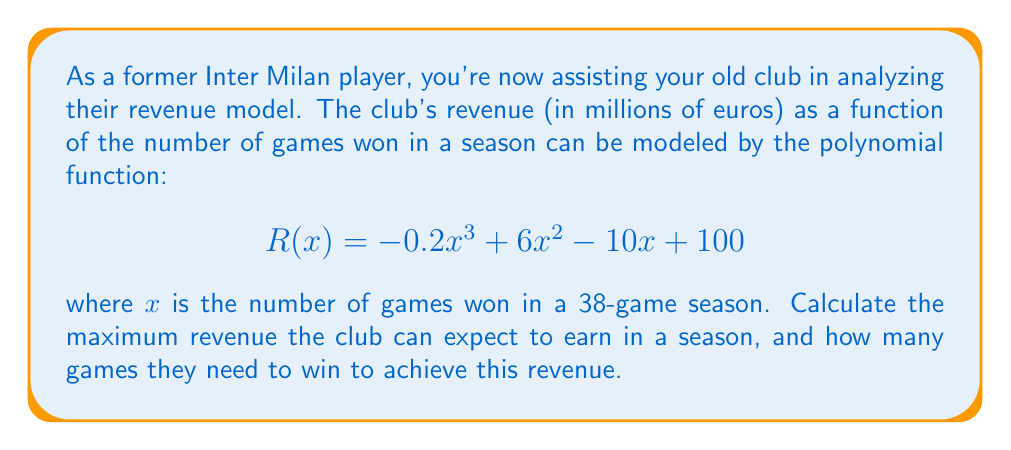Solve this math problem. To find the maximum revenue and the corresponding number of games won, we need to follow these steps:

1) First, we need to find the derivative of the revenue function:
   $$R'(x) = -0.6x^2 + 12x - 10$$

2) To find the maximum, we set the derivative equal to zero and solve for x:
   $$-0.6x^2 + 12x - 10 = 0$$

3) This is a quadratic equation. We can solve it using the quadratic formula:
   $$x = \frac{-b \pm \sqrt{b^2 - 4ac}}{2a}$$
   where $a = -0.6$, $b = 12$, and $c = -10$

4) Plugging in these values:
   $$x = \frac{-12 \pm \sqrt{12^2 - 4(-0.6)(-10)}}{2(-0.6)}$$
   $$= \frac{-12 \pm \sqrt{144 - 24}}{-1.2}$$
   $$= \frac{-12 \pm \sqrt{120}}{-1.2}$$
   $$= \frac{-12 \pm 10.95}{-1.2}$$

5) This gives us two solutions:
   $$x_1 = \frac{-12 + 10.95}{-1.2} \approx 0.875$$
   $$x_2 = \frac{-12 - 10.95}{-1.2} \approx 19.125$$

6) Since we're looking for the maximum revenue, and the leading coefficient of our original function is negative (indicating it opens downward), we choose the larger x-value: 19.125

7) However, since the number of games won must be a whole number, we round this to 19 games.

8) To find the maximum revenue, we plug x = 19 into our original function:
   $$R(19) = -0.2(19)^3 + 6(19)^2 - 10(19) + 100$$
   $$= -0.2(6859) + 6(361) - 190 + 100$$
   $$= -1371.8 + 2166 - 190 + 100$$
   $$= 704.2$$

Therefore, the maximum revenue is approximately 704.2 million euros.
Answer: The club can expect a maximum revenue of approximately 704.2 million euros by winning 19 games in a season. 